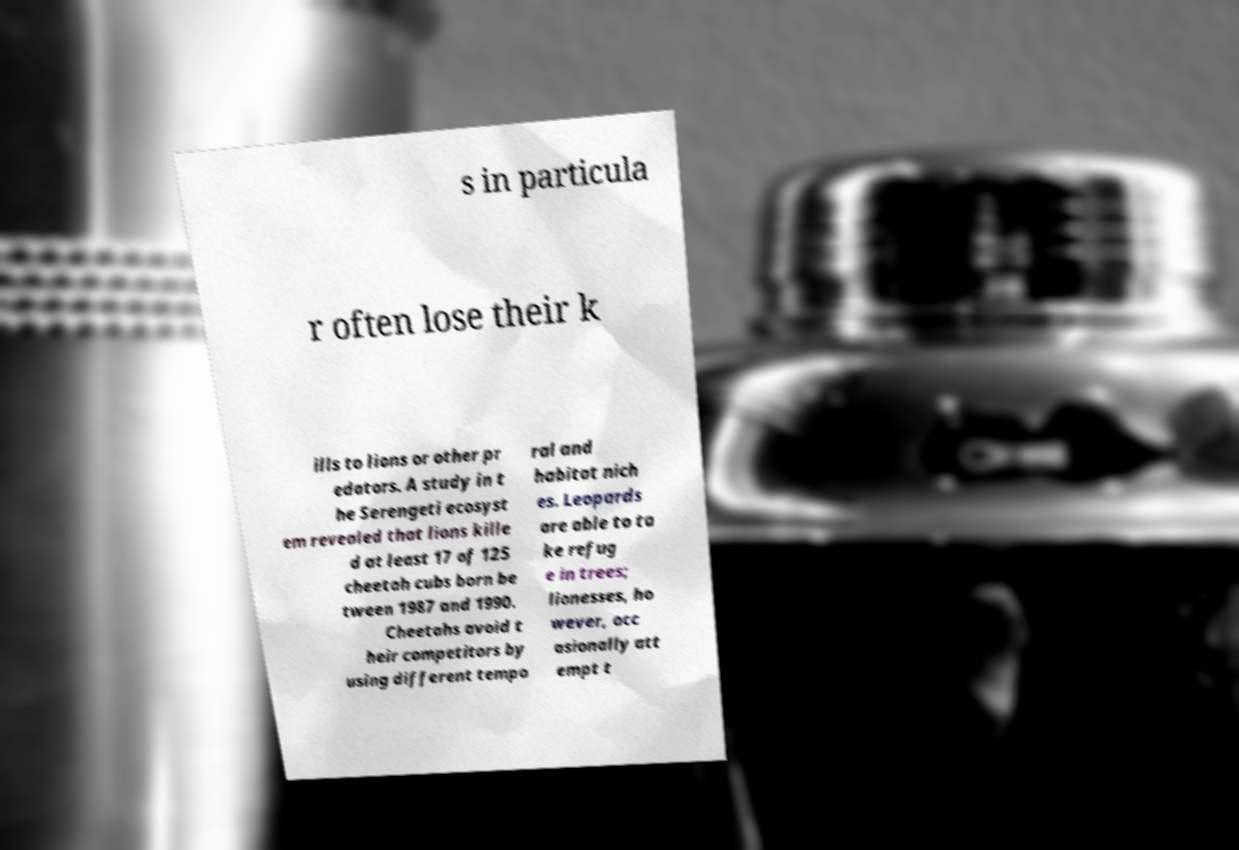There's text embedded in this image that I need extracted. Can you transcribe it verbatim? s in particula r often lose their k ills to lions or other pr edators. A study in t he Serengeti ecosyst em revealed that lions kille d at least 17 of 125 cheetah cubs born be tween 1987 and 1990. Cheetahs avoid t heir competitors by using different tempo ral and habitat nich es. Leopards are able to ta ke refug e in trees; lionesses, ho wever, occ asionally att empt t 